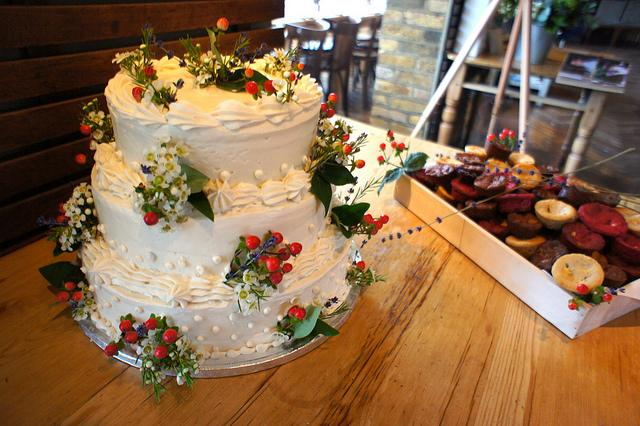Bakers usually charge by the what to make these items? Please explain your reasoning. slice. That said, some also charge by the time it takes to bake, which would mean b and c, and/or by d. 